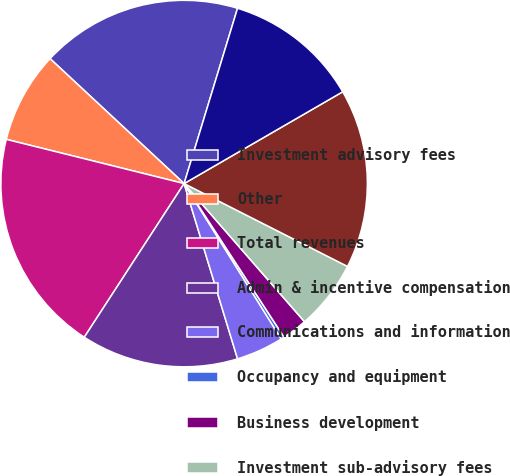Convert chart. <chart><loc_0><loc_0><loc_500><loc_500><pie_chart><fcel>Investment advisory fees<fcel>Other<fcel>Total revenues<fcel>Admin & incentive compensation<fcel>Communications and information<fcel>Occupancy and equipment<fcel>Business development<fcel>Investment sub-advisory fees<fcel>Total expenses<fcel>Income before taxes and<nl><fcel>17.77%<fcel>8.06%<fcel>19.71%<fcel>13.88%<fcel>4.18%<fcel>0.29%<fcel>2.23%<fcel>6.12%<fcel>15.82%<fcel>11.94%<nl></chart> 